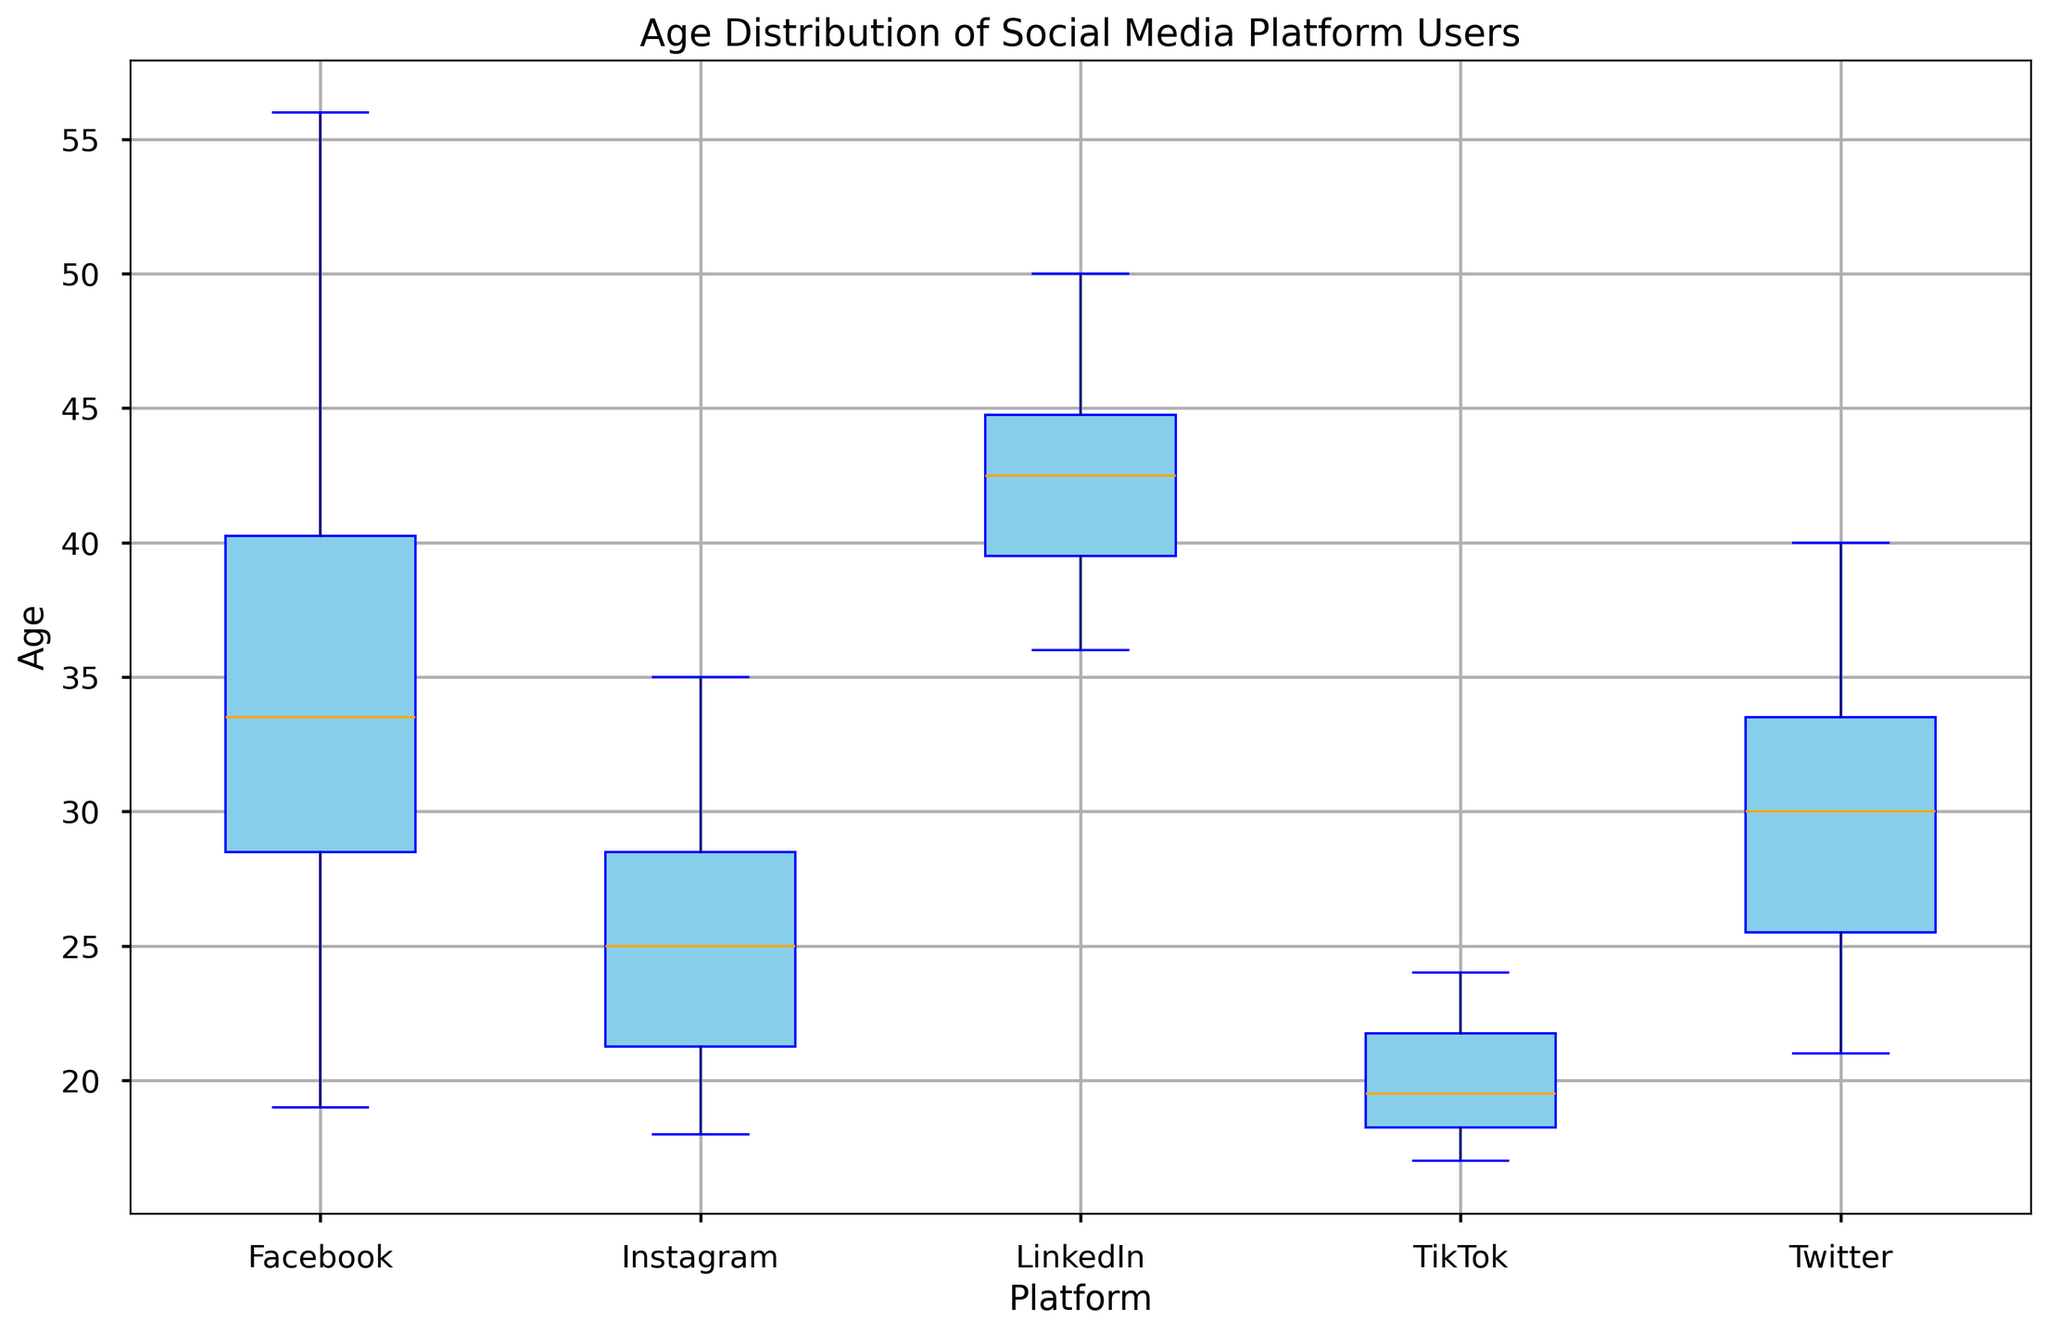What is the median age of LinkedIn users? The orange line inside the box represents the median. For LinkedIn, the median lies slightly above 42.
Answer: 42 Which social media platform has the youngest minimum age of its users? The minimum age is indicated by the bottom whisker of each box plot. TikTok's bottom whisker lies at 17, which is the youngest minimum age compared to the other platforms.
Answer: TikTok Which platform shows the widest age range among its users? The range is given by the difference between the top and bottom whiskers. Facebook shows the widest range, from 19 to 56, suggesting more diverse age distribution.
Answer: Facebook Comparing the median ages, which platform has older users, Facebook or Instagram? The median is represented by the orange line in each box plot. Facebook's median age is around 33, while Instagram’s is around 26. Thus, Facebook has older users.
Answer: Facebook Is the interquartile range (IQR) greater for Twitter or Instagram? The IQR is represented by the height of the box itself. Visually comparing, Twitter’s IQR appears larger than Instagram’s IQR, suggesting more variability within Twitter users' ages.
Answer: Twitter Maximum age of Facebook users The maximum value is indicated by the top whisker. For Facebook, the top whisker is at age 56.
Answer: 56 Which platform has the smallest median age difference from its minimum age? Checking visually, TikTok’s median age (around 19-20) is closest to its minimum age (17), having the smallest difference.
Answer: TikTok Rank the platforms by median age from oldest to youngest. By looking at the position of the orange line in each box plot: LinkedIn (oldest), Facebook, Twitter, Instagram, TikTok (youngest).
Answer: LinkedIn, Facebook, Twitter, Instagram, TikTok Does TikTok have any outliers in its age distribution? Outliers are represented by red markers. TikTok does not have any red markers outside its whiskers, indicating it has no outliers.
Answer: No 